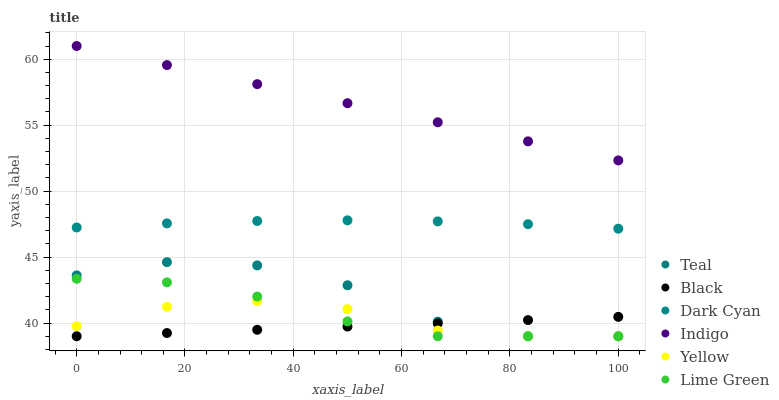Does Black have the minimum area under the curve?
Answer yes or no. Yes. Does Indigo have the maximum area under the curve?
Answer yes or no. Yes. Does Yellow have the minimum area under the curve?
Answer yes or no. No. Does Yellow have the maximum area under the curve?
Answer yes or no. No. Is Indigo the smoothest?
Answer yes or no. Yes. Is Teal the roughest?
Answer yes or no. Yes. Is Yellow the smoothest?
Answer yes or no. No. Is Yellow the roughest?
Answer yes or no. No. Does Yellow have the lowest value?
Answer yes or no. Yes. Does Dark Cyan have the lowest value?
Answer yes or no. No. Does Indigo have the highest value?
Answer yes or no. Yes. Does Yellow have the highest value?
Answer yes or no. No. Is Lime Green less than Indigo?
Answer yes or no. Yes. Is Dark Cyan greater than Lime Green?
Answer yes or no. Yes. Does Yellow intersect Lime Green?
Answer yes or no. Yes. Is Yellow less than Lime Green?
Answer yes or no. No. Is Yellow greater than Lime Green?
Answer yes or no. No. Does Lime Green intersect Indigo?
Answer yes or no. No. 